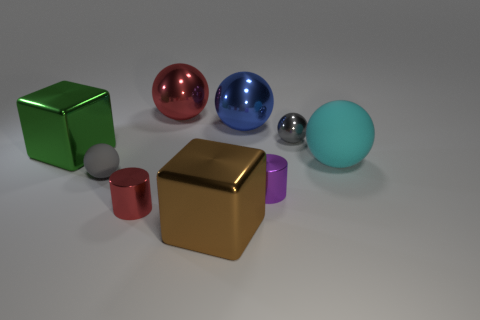Is there a purple thing that has the same material as the large green thing?
Your response must be concise. Yes. There is a blue ball that is the same size as the cyan matte thing; what is its material?
Provide a succinct answer. Metal. There is a large sphere that is right of the small sphere that is right of the red shiny thing behind the cyan matte sphere; what color is it?
Make the answer very short. Cyan. Do the small gray thing that is behind the large green thing and the big thing left of the small red shiny cylinder have the same shape?
Offer a very short reply. No. What number of metal cylinders are there?
Make the answer very short. 2. There is a metal ball that is the same size as the purple shiny cylinder; what color is it?
Your answer should be very brief. Gray. Is the material of the block right of the large green shiny cube the same as the gray ball behind the big green object?
Make the answer very short. Yes. What is the size of the cylinder that is to the right of the red metal thing in front of the large cyan rubber thing?
Provide a succinct answer. Small. What is the material of the large block that is to the right of the red shiny cylinder?
Give a very brief answer. Metal. What number of things are either gray spheres that are behind the green block or tiny objects that are left of the big red ball?
Offer a very short reply. 3. 